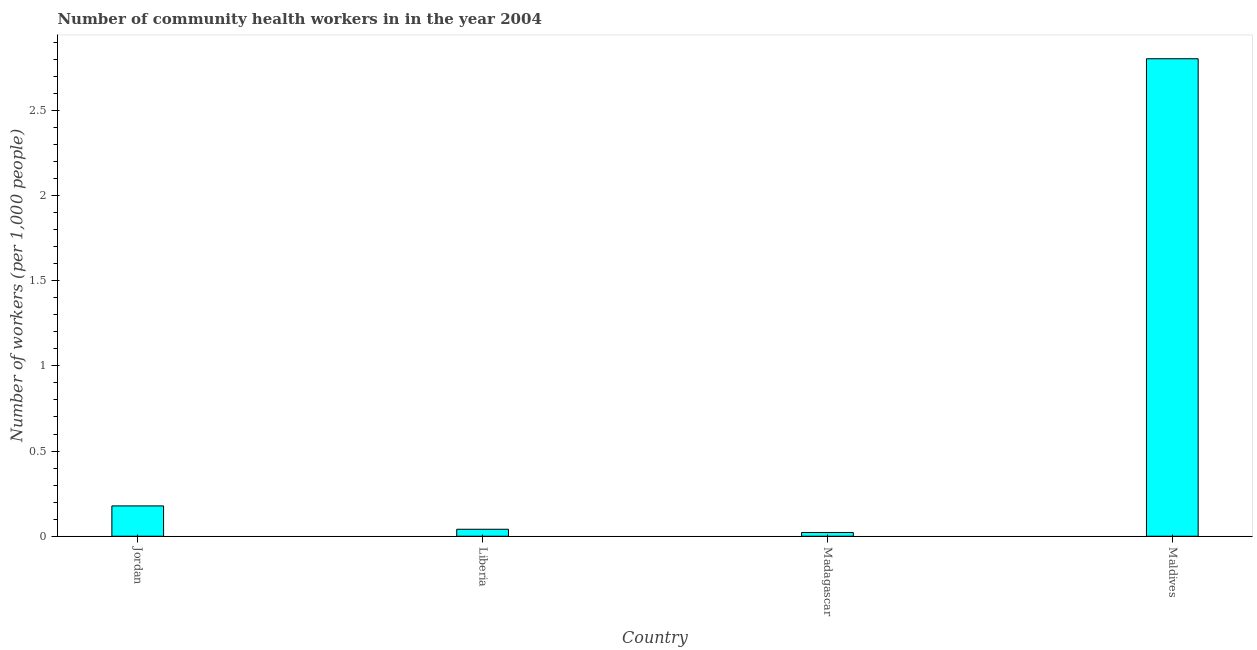What is the title of the graph?
Your answer should be compact. Number of community health workers in in the year 2004. What is the label or title of the X-axis?
Make the answer very short. Country. What is the label or title of the Y-axis?
Your answer should be very brief. Number of workers (per 1,0 people). What is the number of community health workers in Madagascar?
Make the answer very short. 0.02. Across all countries, what is the maximum number of community health workers?
Your answer should be compact. 2.8. Across all countries, what is the minimum number of community health workers?
Provide a short and direct response. 0.02. In which country was the number of community health workers maximum?
Offer a terse response. Maldives. In which country was the number of community health workers minimum?
Offer a terse response. Madagascar. What is the sum of the number of community health workers?
Offer a very short reply. 3.04. What is the difference between the number of community health workers in Liberia and Maldives?
Keep it short and to the point. -2.76. What is the average number of community health workers per country?
Offer a terse response. 0.76. What is the median number of community health workers?
Give a very brief answer. 0.11. In how many countries, is the number of community health workers greater than 0.3 ?
Provide a succinct answer. 1. What is the ratio of the number of community health workers in Madagascar to that in Maldives?
Give a very brief answer. 0.01. Is the number of community health workers in Madagascar less than that in Maldives?
Give a very brief answer. Yes. What is the difference between the highest and the second highest number of community health workers?
Offer a terse response. 2.62. What is the difference between the highest and the lowest number of community health workers?
Provide a short and direct response. 2.78. In how many countries, is the number of community health workers greater than the average number of community health workers taken over all countries?
Your response must be concise. 1. How many countries are there in the graph?
Give a very brief answer. 4. What is the Number of workers (per 1,000 people) in Jordan?
Your answer should be compact. 0.18. What is the Number of workers (per 1,000 people) of Liberia?
Ensure brevity in your answer.  0.04. What is the Number of workers (per 1,000 people) in Madagascar?
Provide a succinct answer. 0.02. What is the Number of workers (per 1,000 people) of Maldives?
Provide a short and direct response. 2.8. What is the difference between the Number of workers (per 1,000 people) in Jordan and Liberia?
Provide a succinct answer. 0.14. What is the difference between the Number of workers (per 1,000 people) in Jordan and Madagascar?
Offer a very short reply. 0.16. What is the difference between the Number of workers (per 1,000 people) in Jordan and Maldives?
Your answer should be compact. -2.62. What is the difference between the Number of workers (per 1,000 people) in Liberia and Madagascar?
Offer a very short reply. 0.02. What is the difference between the Number of workers (per 1,000 people) in Liberia and Maldives?
Provide a short and direct response. -2.76. What is the difference between the Number of workers (per 1,000 people) in Madagascar and Maldives?
Offer a very short reply. -2.78. What is the ratio of the Number of workers (per 1,000 people) in Jordan to that in Liberia?
Give a very brief answer. 4.34. What is the ratio of the Number of workers (per 1,000 people) in Jordan to that in Madagascar?
Offer a very short reply. 8.09. What is the ratio of the Number of workers (per 1,000 people) in Jordan to that in Maldives?
Your answer should be compact. 0.06. What is the ratio of the Number of workers (per 1,000 people) in Liberia to that in Madagascar?
Give a very brief answer. 1.86. What is the ratio of the Number of workers (per 1,000 people) in Liberia to that in Maldives?
Offer a terse response. 0.01. What is the ratio of the Number of workers (per 1,000 people) in Madagascar to that in Maldives?
Provide a succinct answer. 0.01. 